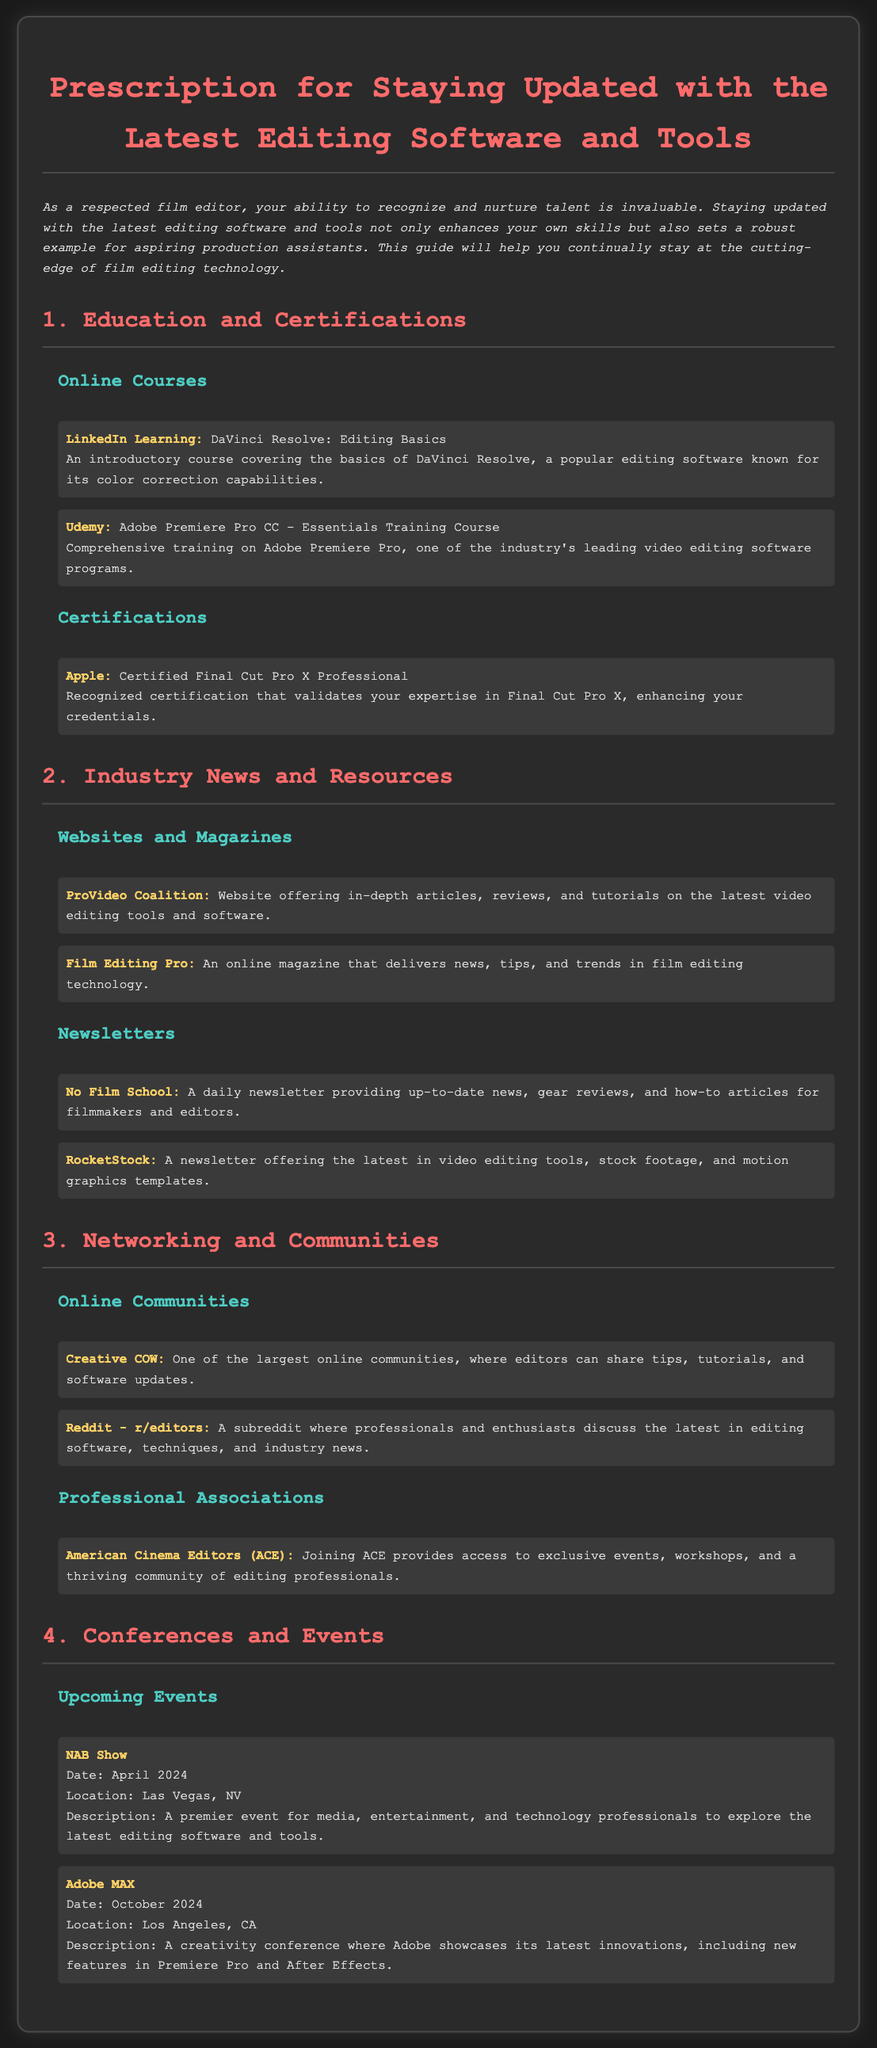what is the title of the document? The title of the document is found at the top and indicates the main focus of the content.
Answer: Prescription for Staying Updated with the Latest Editing Software and Tools which online course covers DaVinci Resolve? The document lists specific online courses under the Education and Certifications section, one of which focuses on DaVinci Resolve.
Answer: LinkedIn Learning: DaVinci Resolve: Editing Basics what certification is from Apple? The document includes a section on certifications where Apple’s certification is mentioned, indicating its recognition in the industry.
Answer: Certified Final Cut Pro X Professional when is the NAB Show scheduled? The document provides specific dates for upcoming events, including the NAB Show, which are clearly indicated.
Answer: April 2024 who can join the American Cinema Editors? Information about professional associations mentions one specific group and its accessibility to interested individuals.
Answer: Anyone (individuals interested in editing) what is a benefit of joining ACE? The document discusses the advantages of belonging to professional associations, particularly highlighting the access they provide.
Answer: Exclusive events what is a resource mentioned for film editing news? The document lists various resources and publications under the Industry News and Resources section that provide current industry information.
Answer: Film Editing Pro which online community is mentioned for editors? The document specifies certain online platforms where editors can interact and share resources.
Answer: Creative COW what is the purpose of the Adobe MAX conference? The document describes the focus and relevance of upcoming events, providing insight into what attendees can expect.
Answer: A creativity conference 